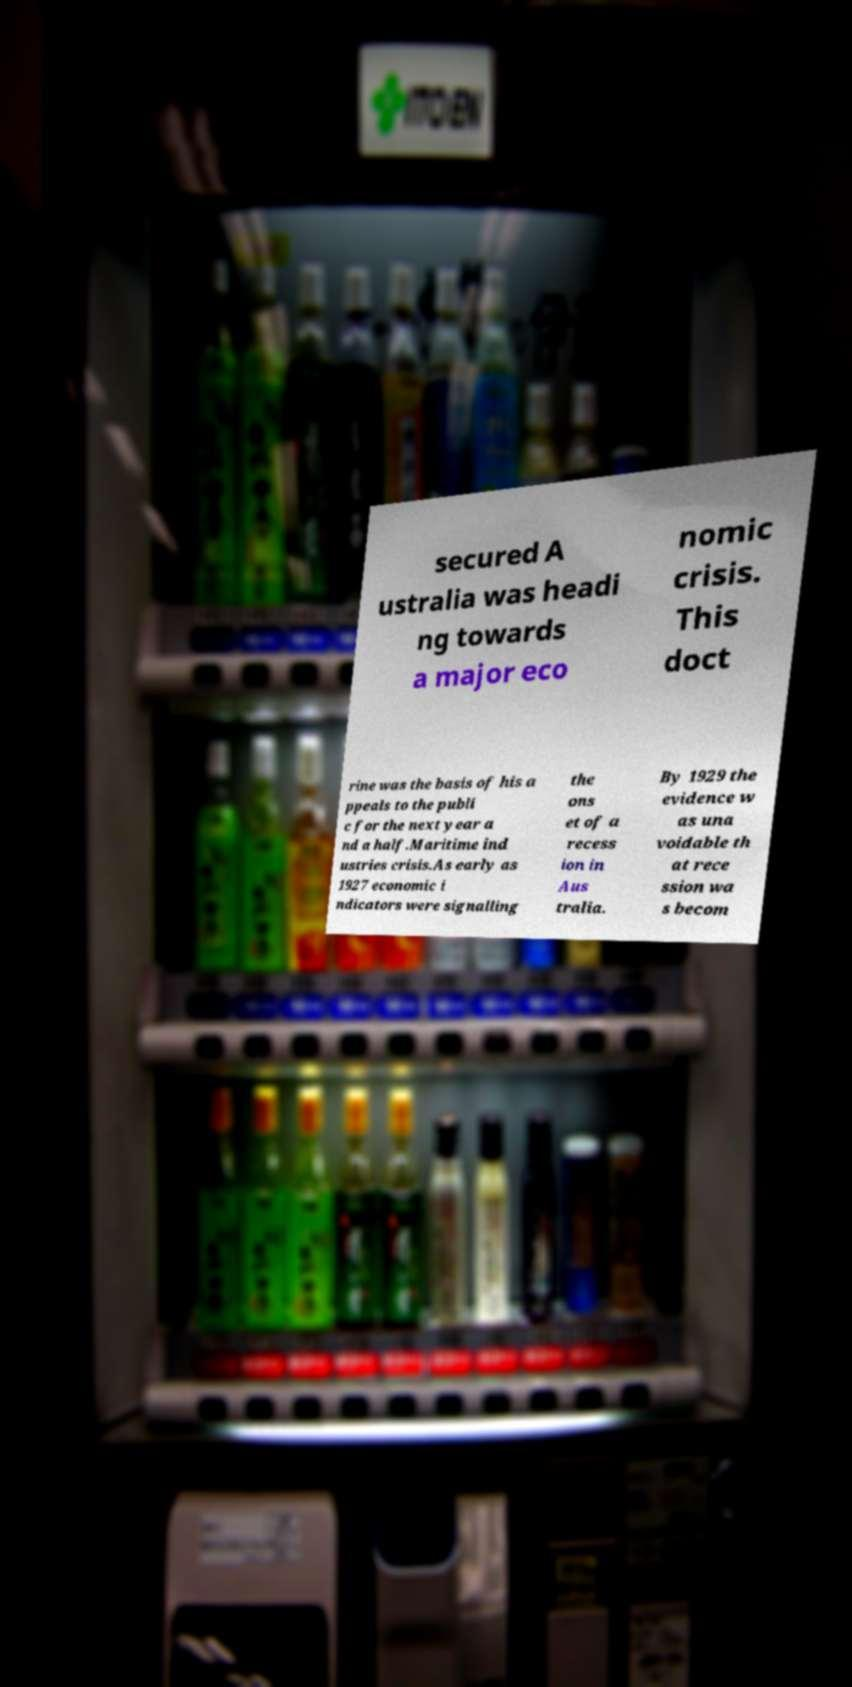Please identify and transcribe the text found in this image. secured A ustralia was headi ng towards a major eco nomic crisis. This doct rine was the basis of his a ppeals to the publi c for the next year a nd a half.Maritime ind ustries crisis.As early as 1927 economic i ndicators were signalling the ons et of a recess ion in Aus tralia. By 1929 the evidence w as una voidable th at rece ssion wa s becom 